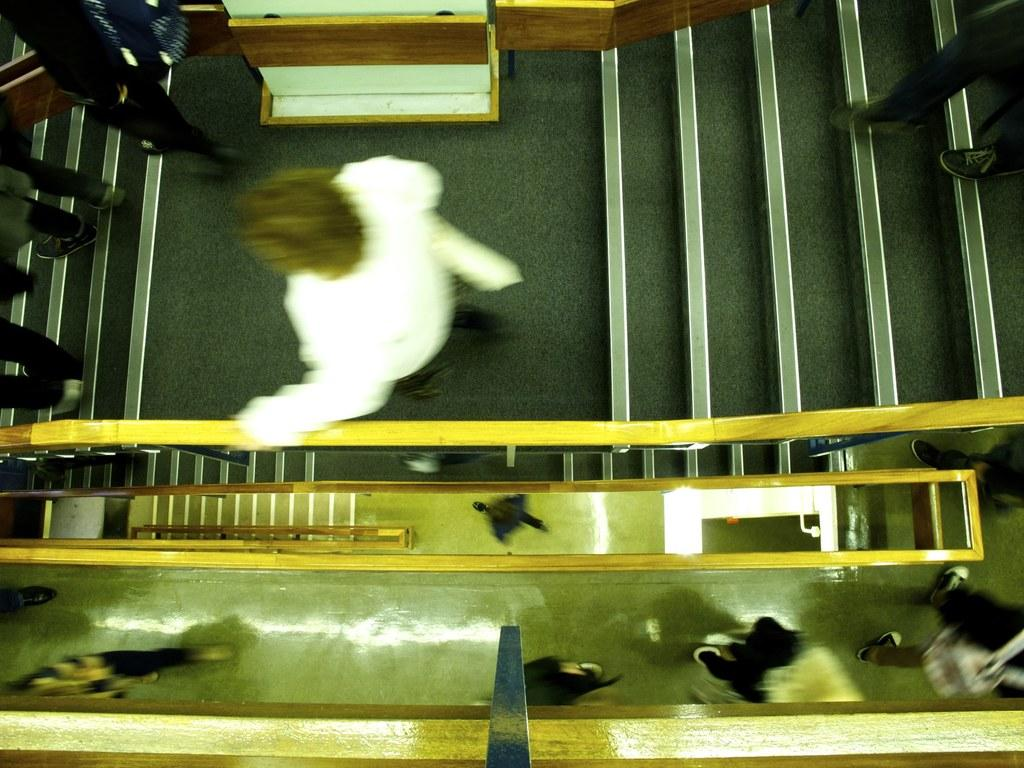Who or what can be seen in the image? There are people in the image. What are the people doing in the image? The people are climbing down the stairs. How many floors are visible in the image? There are multiple floors visible in the image. Is there any other image or representation of a person in the scene? Yes, there is an image of a person in the scene. What type of quartz can be seen in the image? There is no quartz present in the image. Can you tell me which person in the image is having an argument with someone else? There is no indication of an argument or any conflict in the image. 